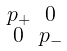Convert formula to latex. <formula><loc_0><loc_0><loc_500><loc_500>\begin{smallmatrix} p _ { + } & 0 \\ 0 & p _ { - } \end{smallmatrix}</formula> 